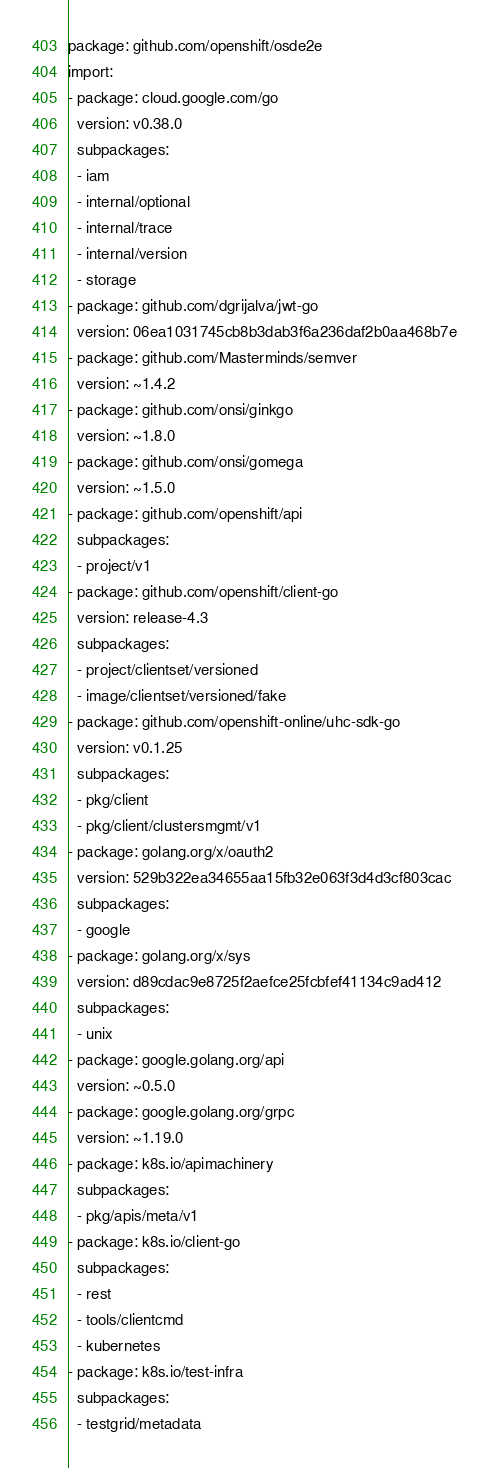<code> <loc_0><loc_0><loc_500><loc_500><_YAML_>package: github.com/openshift/osde2e
import:
- package: cloud.google.com/go
  version: v0.38.0
  subpackages:
  - iam
  - internal/optional
  - internal/trace
  - internal/version
  - storage
- package: github.com/dgrijalva/jwt-go
  version: 06ea1031745cb8b3dab3f6a236daf2b0aa468b7e
- package: github.com/Masterminds/semver
  version: ~1.4.2
- package: github.com/onsi/ginkgo
  version: ~1.8.0
- package: github.com/onsi/gomega
  version: ~1.5.0
- package: github.com/openshift/api
  subpackages:
  - project/v1
- package: github.com/openshift/client-go
  version: release-4.3
  subpackages:
  - project/clientset/versioned
  - image/clientset/versioned/fake
- package: github.com/openshift-online/uhc-sdk-go
  version: v0.1.25
  subpackages:
  - pkg/client
  - pkg/client/clustersmgmt/v1
- package: golang.org/x/oauth2
  version: 529b322ea34655aa15fb32e063f3d4d3cf803cac
  subpackages:
  - google
- package: golang.org/x/sys
  version: d89cdac9e8725f2aefce25fcbfef41134c9ad412
  subpackages:
  - unix
- package: google.golang.org/api
  version: ~0.5.0
- package: google.golang.org/grpc
  version: ~1.19.0
- package: k8s.io/apimachinery
  subpackages:
  - pkg/apis/meta/v1
- package: k8s.io/client-go
  subpackages:
  - rest
  - tools/clientcmd
  - kubernetes
- package: k8s.io/test-infra
  subpackages:
  - testgrid/metadata
</code> 